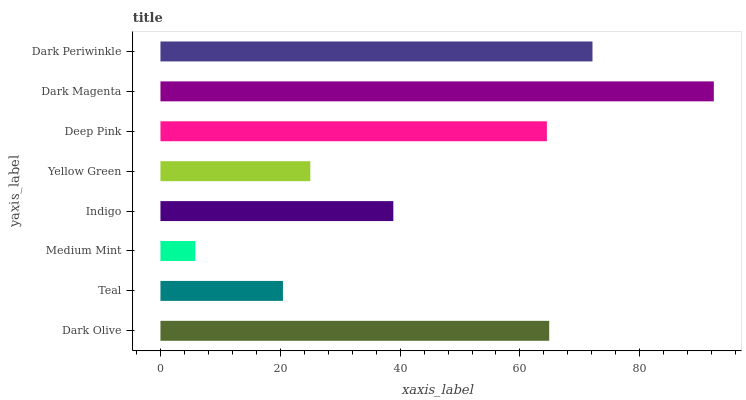Is Medium Mint the minimum?
Answer yes or no. Yes. Is Dark Magenta the maximum?
Answer yes or no. Yes. Is Teal the minimum?
Answer yes or no. No. Is Teal the maximum?
Answer yes or no. No. Is Dark Olive greater than Teal?
Answer yes or no. Yes. Is Teal less than Dark Olive?
Answer yes or no. Yes. Is Teal greater than Dark Olive?
Answer yes or no. No. Is Dark Olive less than Teal?
Answer yes or no. No. Is Deep Pink the high median?
Answer yes or no. Yes. Is Indigo the low median?
Answer yes or no. Yes. Is Teal the high median?
Answer yes or no. No. Is Dark Olive the low median?
Answer yes or no. No. 